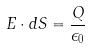Convert formula to latex. <formula><loc_0><loc_0><loc_500><loc_500>E \cdot d S = \frac { Q } { \epsilon _ { 0 } }</formula> 